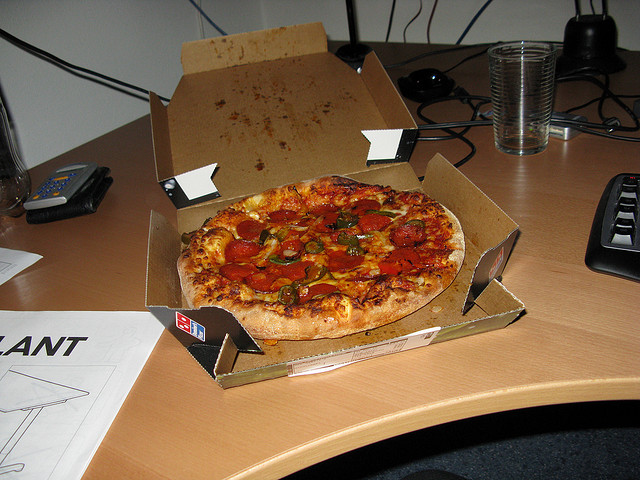Explain the visual content of the image in great detail. The image captures a vivid scene of a typical office workspace during a meal break, showcasing a large, colorful pizza full of toppings such as pepperoni and green peppers placed in the center of a slightly cluttered office desk. The pizza, almost entirely whole, rests inside its cardboard delivery box. To the left of the pizza box, there's a simple black calculator next to a leather wallet, suggesting a recent or upcoming financial transaction. On the right side of the image, a computer keyboard is visible, hinting at ongoing work. Behind these items, a clear glass of water is seen, along with parts of a monitor that suggest the desk is part of a functional office setup. The papers scattered around the back of the desk and some faintly visible drawings add a touch of personalized chaos to the environment, indicative of a workspace that is actively used. 